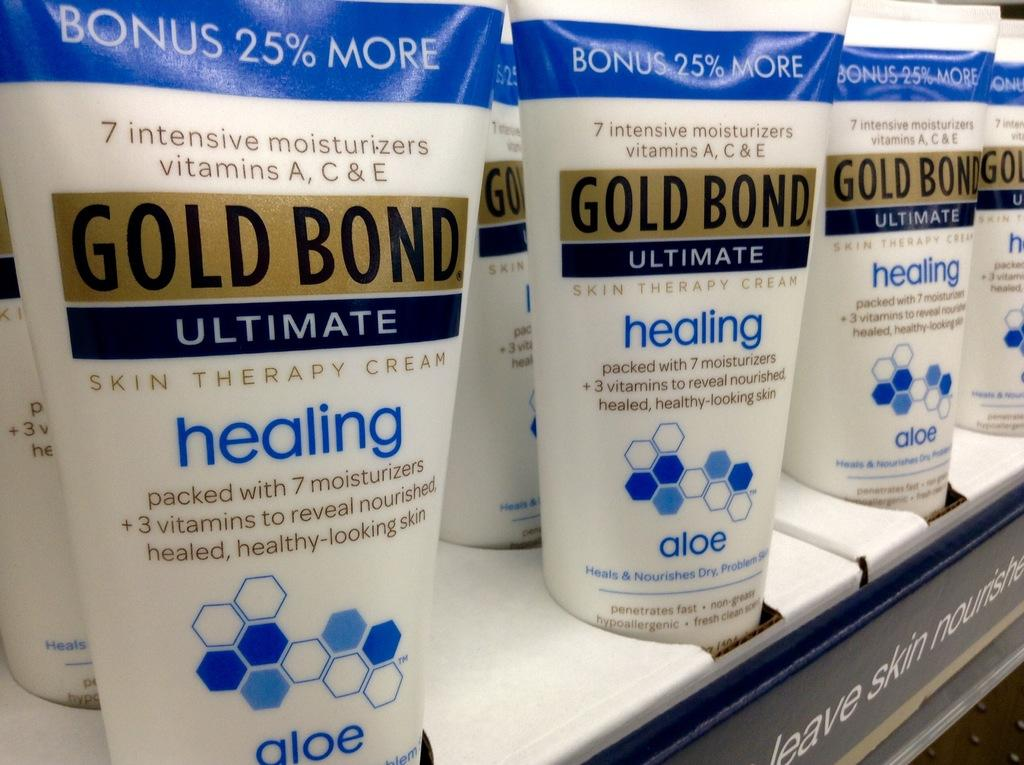<image>
Describe the image concisely. A store display of Gold Bond Ultimate skin therapy cream. 